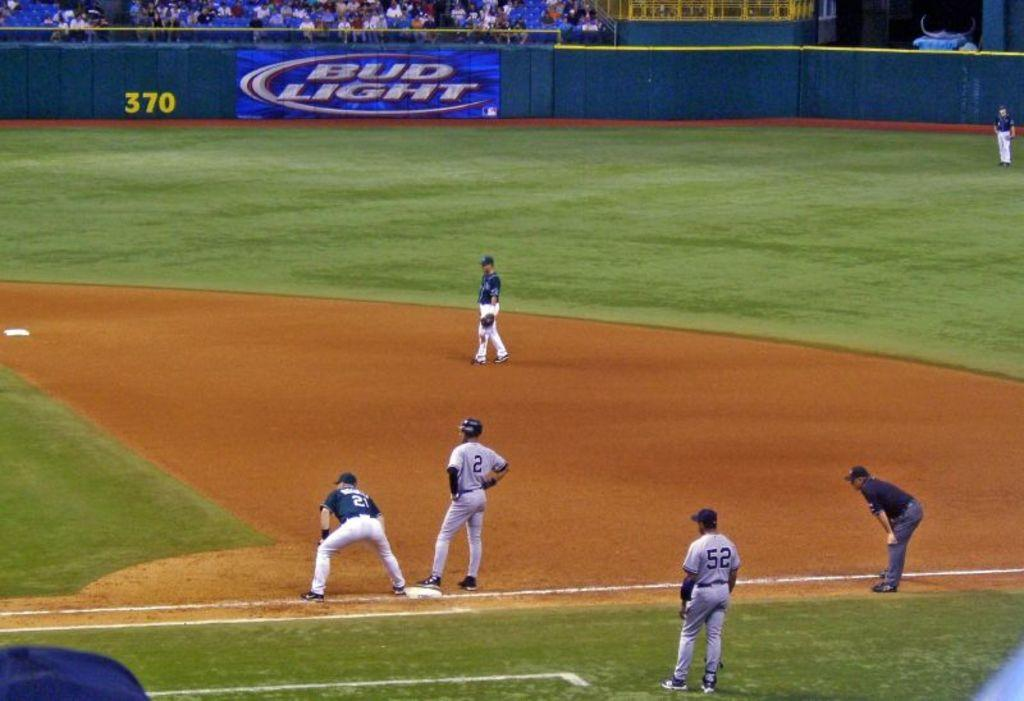<image>
Create a compact narrative representing the image presented. Bud Light is prominently advertised in the background of this baseball game. 